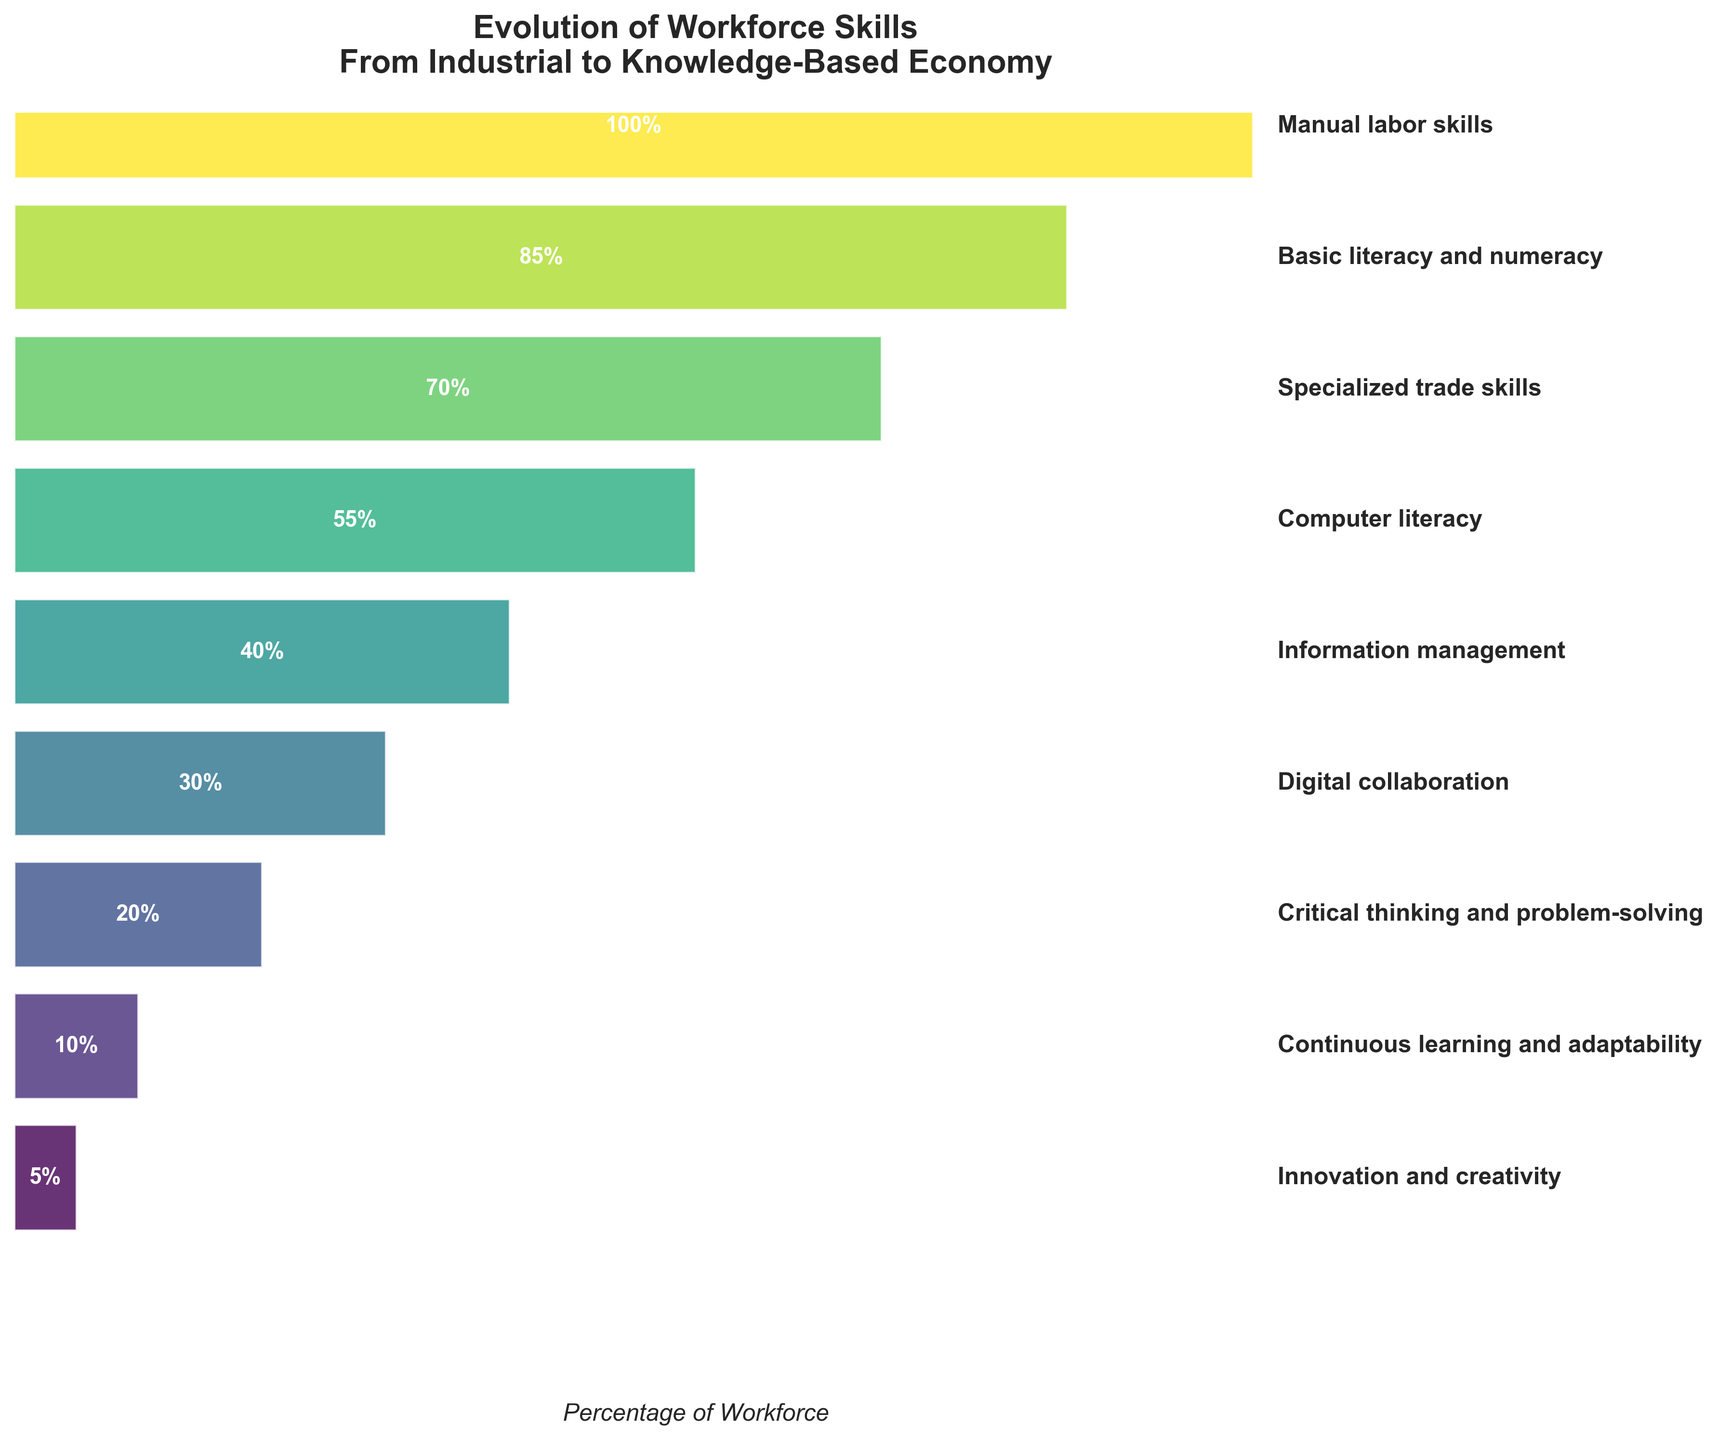What is the title of the figure? The title is typically placed at the top of the figure and is meant to give an overview of what the figure represents. In this case, the title provided is "Evolution of Workforce Skills From Industrial to Knowledge-Based Economy."
Answer: Evolution of Workforce Skills From Industrial to Knowledge-Based Economy How many steps are shown in the funnel chart? Count the individual steps listed on the y-axis of the funnel chart. The chart lists nine steps as indicated by the "Step" data.
Answer: Nine Which step has the lowest percentage in the funnel chart? Identify the step labeled with the smallest percentage of the workforce, which according to the data is at the bottom of the funnel. The smallest percentage listed is "Innovation and creativity" at 5%.
Answer: Innovation and creativity By how much does the percentage decrease from 'Manual labor skills' to 'Basic literacy and numeracy'? Find the difference between the percentages of 'Manual labor skills' (100%) and 'Basic literacy and numeracy' (85%). Subtract the smaller percentage from the larger one: 100% - 85%.
Answer: 15% What percentage of the workforce has 'Critical thinking and problem-solving' skills? Look for the 'Critical thinking and problem-solving' step in the funnel chart. The corresponding percentage listed in the visual is 20%.
Answer: 20% How many steps are there between 'Manual labor skills' and 'Innovation and creativity'? Count the steps listed between 'Manual labor skills' and 'Innovation and creativity' in the funnel chart. These steps include: Basic literacy and numeracy, Specialized trade skills, Computer literacy, Information management, Digital collaboration, Critical thinking and problem-solving, Continuous learning and adaptability. In total, there are 7 steps.
Answer: Seven Compare the percentage of workforce with 'Computer literacy' to those with 'Information management'. Which is higher and by how much? Identify the percentages for 'Computer literacy' (55%) and 'Information management' (40%). Compute the difference: 55% - 40%. 'Computer literacy' has a higher percentage by 15%.
Answer: Computer literacy by 15% What is the cumulative percentage of workforce skills from 'Information management' to 'Innovation and creativity'? Add the percentages of the steps from 'Information management' (40%), 'Digital collaboration' (30%), 'Critical thinking and problem-solving' (20%), 'Continuous learning and adaptability' (10%), and 'Innovation and creativity' (5%). That's 40% + 30% + 20% + 10% + 5%. The cumulative percentage is 105%.
Answer: 105% Is the percentage of the workforce with 'Basic literacy and numeracy' skills greater than twice the percentage with 'Digital collaboration' skills? Determine the percentages for 'Basic literacy and numeracy' (85%) and 'Digital collaboration' (30%). Multiply the percentage of 'Digital collaboration' by 2: 30% * 2 = 60%. Since 85% is greater than 60%, the answer is yes.
Answer: Yes 